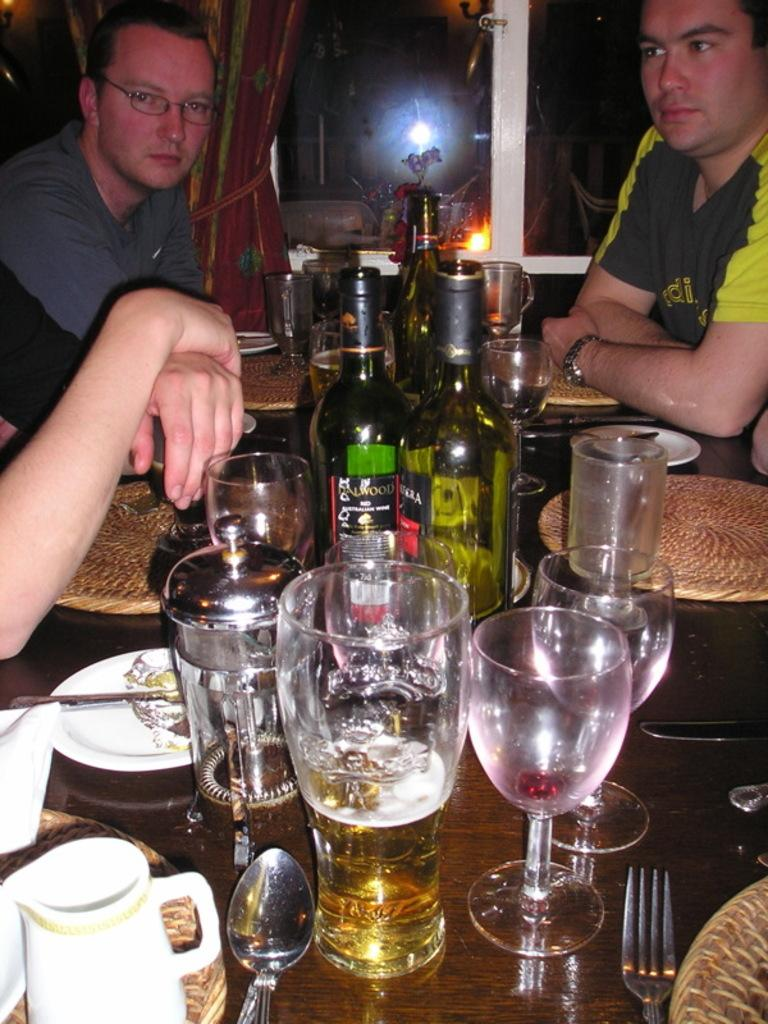How many people are present in the image? There are three persons in the image. What is the main piece of furniture in the image? There is a table in the image. What items can be seen on the table? There are glasses, bottles, and plates on the table. What architectural feature is visible in the background of the image? There is a glass window in the background of the image. Is there any window treatment present in the image? Yes, there is a curtain associated with the glass window. How many giants are visible in the image? There are no giants present in the image. What type of property is being discussed in the image? The image does not depict or discuss any specific property. 